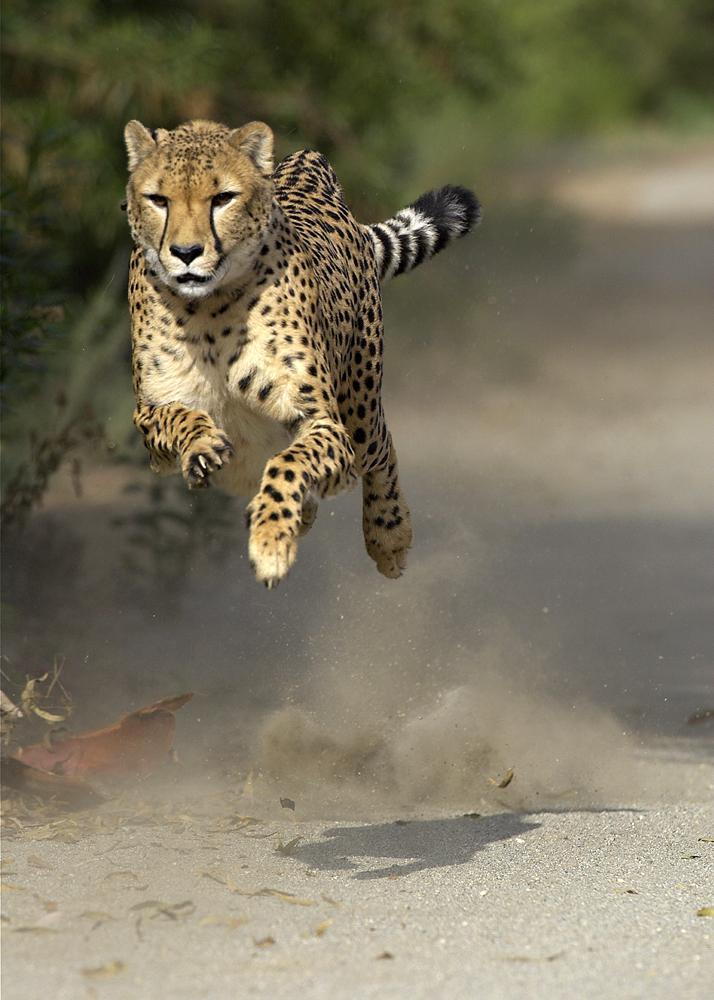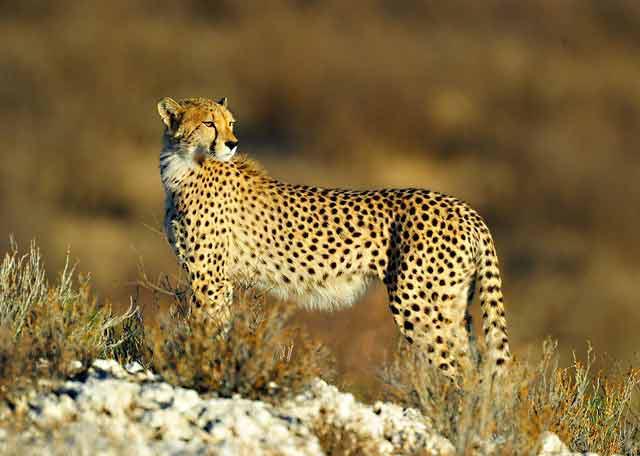The first image is the image on the left, the second image is the image on the right. Given the left and right images, does the statement "the left and right image contains the same number of cheetahs jumping in the air." hold true? Answer yes or no. No. The first image is the image on the left, the second image is the image on the right. Considering the images on both sides, is "Each image contains exactly one cheetah, and each of the cheetahs depicted is in a bounding pose, with at least both front paws off the ground." valid? Answer yes or no. No. 